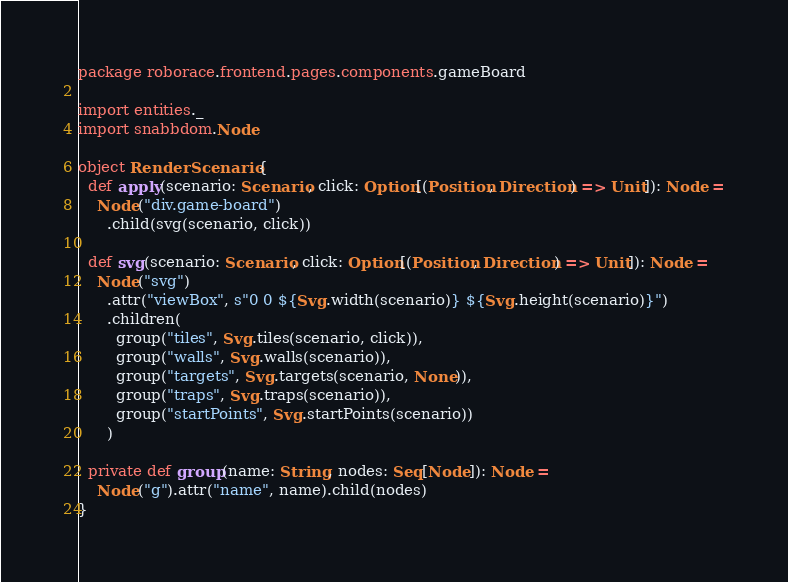<code> <loc_0><loc_0><loc_500><loc_500><_Scala_>package roborace.frontend.pages.components.gameBoard

import entities._
import snabbdom.Node

object RenderScenario {
  def apply(scenario: Scenario, click: Option[(Position, Direction) => Unit]): Node =
    Node("div.game-board")
      .child(svg(scenario, click))

  def svg(scenario: Scenario, click: Option[(Position, Direction) => Unit]): Node =
    Node("svg")
      .attr("viewBox", s"0 0 ${Svg.width(scenario)} ${Svg.height(scenario)}")
      .children(
        group("tiles", Svg.tiles(scenario, click)),
        group("walls", Svg.walls(scenario)),
        group("targets", Svg.targets(scenario, None)),
        group("traps", Svg.traps(scenario)),
        group("startPoints", Svg.startPoints(scenario))
      )

  private def group(name: String, nodes: Seq[Node]): Node =
    Node("g").attr("name", name).child(nodes)
}
</code> 